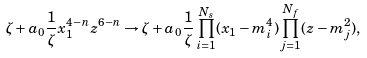<formula> <loc_0><loc_0><loc_500><loc_500>\zeta + a _ { 0 } \frac { 1 } { \zeta } x _ { 1 } ^ { 4 - n } z ^ { 6 - n } \to \zeta + a _ { 0 } \frac { 1 } { \zeta } \prod _ { i = 1 } ^ { N _ { s } } ( x _ { 1 } - m _ { i } ^ { 4 } ) \prod _ { j = 1 } ^ { N _ { f } } ( z - m _ { j } ^ { 2 } ) ,</formula> 